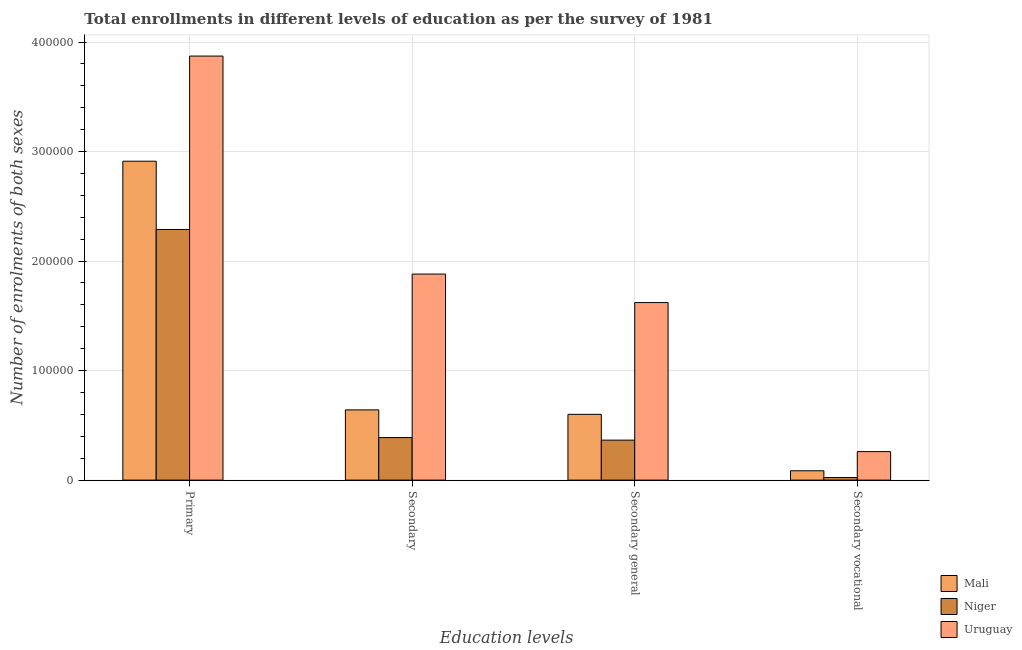How many different coloured bars are there?
Provide a succinct answer. 3. How many groups of bars are there?
Ensure brevity in your answer.  4. Are the number of bars on each tick of the X-axis equal?
Your answer should be compact. Yes. How many bars are there on the 1st tick from the left?
Ensure brevity in your answer.  3. What is the label of the 2nd group of bars from the left?
Make the answer very short. Secondary. What is the number of enrolments in secondary general education in Uruguay?
Provide a short and direct response. 1.62e+05. Across all countries, what is the maximum number of enrolments in secondary general education?
Provide a short and direct response. 1.62e+05. Across all countries, what is the minimum number of enrolments in primary education?
Provide a short and direct response. 2.29e+05. In which country was the number of enrolments in secondary general education maximum?
Make the answer very short. Uruguay. In which country was the number of enrolments in secondary education minimum?
Your answer should be compact. Niger. What is the total number of enrolments in secondary vocational education in the graph?
Provide a succinct answer. 3.69e+04. What is the difference between the number of enrolments in primary education in Uruguay and that in Mali?
Your answer should be compact. 9.60e+04. What is the difference between the number of enrolments in secondary general education in Niger and the number of enrolments in secondary education in Mali?
Your answer should be very brief. -2.76e+04. What is the average number of enrolments in secondary education per country?
Offer a terse response. 9.70e+04. What is the difference between the number of enrolments in secondary general education and number of enrolments in primary education in Mali?
Offer a terse response. -2.31e+05. What is the ratio of the number of enrolments in secondary education in Niger to that in Uruguay?
Offer a very short reply. 0.21. Is the number of enrolments in secondary vocational education in Mali less than that in Uruguay?
Your answer should be compact. Yes. Is the difference between the number of enrolments in secondary education in Niger and Mali greater than the difference between the number of enrolments in primary education in Niger and Mali?
Ensure brevity in your answer.  Yes. What is the difference between the highest and the second highest number of enrolments in secondary general education?
Give a very brief answer. 1.02e+05. What is the difference between the highest and the lowest number of enrolments in secondary education?
Your answer should be very brief. 1.49e+05. Is the sum of the number of enrolments in secondary vocational education in Niger and Uruguay greater than the maximum number of enrolments in secondary general education across all countries?
Ensure brevity in your answer.  No. What does the 2nd bar from the left in Primary represents?
Your answer should be compact. Niger. What does the 2nd bar from the right in Secondary represents?
Offer a very short reply. Niger. Where does the legend appear in the graph?
Offer a very short reply. Bottom right. How many legend labels are there?
Provide a succinct answer. 3. What is the title of the graph?
Your response must be concise. Total enrollments in different levels of education as per the survey of 1981. Does "Nicaragua" appear as one of the legend labels in the graph?
Provide a succinct answer. No. What is the label or title of the X-axis?
Offer a very short reply. Education levels. What is the label or title of the Y-axis?
Provide a succinct answer. Number of enrolments of both sexes. What is the Number of enrolments of both sexes in Mali in Primary?
Offer a very short reply. 2.91e+05. What is the Number of enrolments of both sexes of Niger in Primary?
Give a very brief answer. 2.29e+05. What is the Number of enrolments of both sexes in Uruguay in Primary?
Keep it short and to the point. 3.87e+05. What is the Number of enrolments of both sexes in Mali in Secondary?
Your answer should be compact. 6.41e+04. What is the Number of enrolments of both sexes of Niger in Secondary?
Provide a succinct answer. 3.89e+04. What is the Number of enrolments of both sexes in Uruguay in Secondary?
Offer a very short reply. 1.88e+05. What is the Number of enrolments of both sexes in Mali in Secondary general?
Provide a short and direct response. 6.01e+04. What is the Number of enrolments of both sexes of Niger in Secondary general?
Make the answer very short. 3.65e+04. What is the Number of enrolments of both sexes in Uruguay in Secondary general?
Offer a terse response. 1.62e+05. What is the Number of enrolments of both sexes of Mali in Secondary vocational?
Your answer should be very brief. 8537. What is the Number of enrolments of both sexes of Niger in Secondary vocational?
Provide a succinct answer. 2351. What is the Number of enrolments of both sexes in Uruguay in Secondary vocational?
Make the answer very short. 2.60e+04. Across all Education levels, what is the maximum Number of enrolments of both sexes in Mali?
Ensure brevity in your answer.  2.91e+05. Across all Education levels, what is the maximum Number of enrolments of both sexes in Niger?
Keep it short and to the point. 2.29e+05. Across all Education levels, what is the maximum Number of enrolments of both sexes in Uruguay?
Offer a terse response. 3.87e+05. Across all Education levels, what is the minimum Number of enrolments of both sexes of Mali?
Offer a terse response. 8537. Across all Education levels, what is the minimum Number of enrolments of both sexes in Niger?
Give a very brief answer. 2351. Across all Education levels, what is the minimum Number of enrolments of both sexes of Uruguay?
Your response must be concise. 2.60e+04. What is the total Number of enrolments of both sexes of Mali in the graph?
Ensure brevity in your answer.  4.24e+05. What is the total Number of enrolments of both sexes in Niger in the graph?
Provide a succinct answer. 3.07e+05. What is the total Number of enrolments of both sexes in Uruguay in the graph?
Ensure brevity in your answer.  7.63e+05. What is the difference between the Number of enrolments of both sexes in Mali in Primary and that in Secondary?
Provide a short and direct response. 2.27e+05. What is the difference between the Number of enrolments of both sexes of Niger in Primary and that in Secondary?
Your response must be concise. 1.90e+05. What is the difference between the Number of enrolments of both sexes of Uruguay in Primary and that in Secondary?
Keep it short and to the point. 1.99e+05. What is the difference between the Number of enrolments of both sexes of Mali in Primary and that in Secondary general?
Provide a succinct answer. 2.31e+05. What is the difference between the Number of enrolments of both sexes in Niger in Primary and that in Secondary general?
Make the answer very short. 1.92e+05. What is the difference between the Number of enrolments of both sexes in Uruguay in Primary and that in Secondary general?
Make the answer very short. 2.25e+05. What is the difference between the Number of enrolments of both sexes in Mali in Primary and that in Secondary vocational?
Provide a short and direct response. 2.83e+05. What is the difference between the Number of enrolments of both sexes in Niger in Primary and that in Secondary vocational?
Ensure brevity in your answer.  2.27e+05. What is the difference between the Number of enrolments of both sexes in Uruguay in Primary and that in Secondary vocational?
Keep it short and to the point. 3.61e+05. What is the difference between the Number of enrolments of both sexes of Mali in Secondary and that in Secondary general?
Provide a short and direct response. 4059. What is the difference between the Number of enrolments of both sexes in Niger in Secondary and that in Secondary general?
Provide a succinct answer. 2351. What is the difference between the Number of enrolments of both sexes of Uruguay in Secondary and that in Secondary general?
Your answer should be very brief. 2.60e+04. What is the difference between the Number of enrolments of both sexes of Mali in Secondary and that in Secondary vocational?
Offer a terse response. 5.56e+04. What is the difference between the Number of enrolments of both sexes in Niger in Secondary and that in Secondary vocational?
Make the answer very short. 3.65e+04. What is the difference between the Number of enrolments of both sexes of Uruguay in Secondary and that in Secondary vocational?
Offer a terse response. 1.62e+05. What is the difference between the Number of enrolments of both sexes in Mali in Secondary general and that in Secondary vocational?
Provide a succinct answer. 5.15e+04. What is the difference between the Number of enrolments of both sexes of Niger in Secondary general and that in Secondary vocational?
Give a very brief answer. 3.42e+04. What is the difference between the Number of enrolments of both sexes in Uruguay in Secondary general and that in Secondary vocational?
Your answer should be compact. 1.36e+05. What is the difference between the Number of enrolments of both sexes in Mali in Primary and the Number of enrolments of both sexes in Niger in Secondary?
Your response must be concise. 2.52e+05. What is the difference between the Number of enrolments of both sexes of Mali in Primary and the Number of enrolments of both sexes of Uruguay in Secondary?
Offer a very short reply. 1.03e+05. What is the difference between the Number of enrolments of both sexes in Niger in Primary and the Number of enrolments of both sexes in Uruguay in Secondary?
Your response must be concise. 4.07e+04. What is the difference between the Number of enrolments of both sexes of Mali in Primary and the Number of enrolments of both sexes of Niger in Secondary general?
Ensure brevity in your answer.  2.55e+05. What is the difference between the Number of enrolments of both sexes of Mali in Primary and the Number of enrolments of both sexes of Uruguay in Secondary general?
Provide a short and direct response. 1.29e+05. What is the difference between the Number of enrolments of both sexes in Niger in Primary and the Number of enrolments of both sexes in Uruguay in Secondary general?
Ensure brevity in your answer.  6.67e+04. What is the difference between the Number of enrolments of both sexes in Mali in Primary and the Number of enrolments of both sexes in Niger in Secondary vocational?
Your answer should be very brief. 2.89e+05. What is the difference between the Number of enrolments of both sexes in Mali in Primary and the Number of enrolments of both sexes in Uruguay in Secondary vocational?
Make the answer very short. 2.65e+05. What is the difference between the Number of enrolments of both sexes of Niger in Primary and the Number of enrolments of both sexes of Uruguay in Secondary vocational?
Keep it short and to the point. 2.03e+05. What is the difference between the Number of enrolments of both sexes of Mali in Secondary and the Number of enrolments of both sexes of Niger in Secondary general?
Offer a very short reply. 2.76e+04. What is the difference between the Number of enrolments of both sexes in Mali in Secondary and the Number of enrolments of both sexes in Uruguay in Secondary general?
Your answer should be very brief. -9.80e+04. What is the difference between the Number of enrolments of both sexes in Niger in Secondary and the Number of enrolments of both sexes in Uruguay in Secondary general?
Offer a terse response. -1.23e+05. What is the difference between the Number of enrolments of both sexes of Mali in Secondary and the Number of enrolments of both sexes of Niger in Secondary vocational?
Provide a short and direct response. 6.18e+04. What is the difference between the Number of enrolments of both sexes of Mali in Secondary and the Number of enrolments of both sexes of Uruguay in Secondary vocational?
Offer a very short reply. 3.81e+04. What is the difference between the Number of enrolments of both sexes in Niger in Secondary and the Number of enrolments of both sexes in Uruguay in Secondary vocational?
Ensure brevity in your answer.  1.28e+04. What is the difference between the Number of enrolments of both sexes in Mali in Secondary general and the Number of enrolments of both sexes in Niger in Secondary vocational?
Keep it short and to the point. 5.77e+04. What is the difference between the Number of enrolments of both sexes of Mali in Secondary general and the Number of enrolments of both sexes of Uruguay in Secondary vocational?
Give a very brief answer. 3.40e+04. What is the difference between the Number of enrolments of both sexes of Niger in Secondary general and the Number of enrolments of both sexes of Uruguay in Secondary vocational?
Keep it short and to the point. 1.05e+04. What is the average Number of enrolments of both sexes in Mali per Education levels?
Give a very brief answer. 1.06e+05. What is the average Number of enrolments of both sexes of Niger per Education levels?
Ensure brevity in your answer.  7.66e+04. What is the average Number of enrolments of both sexes in Uruguay per Education levels?
Offer a terse response. 1.91e+05. What is the difference between the Number of enrolments of both sexes in Mali and Number of enrolments of both sexes in Niger in Primary?
Offer a terse response. 6.23e+04. What is the difference between the Number of enrolments of both sexes of Mali and Number of enrolments of both sexes of Uruguay in Primary?
Keep it short and to the point. -9.60e+04. What is the difference between the Number of enrolments of both sexes of Niger and Number of enrolments of both sexes of Uruguay in Primary?
Offer a terse response. -1.58e+05. What is the difference between the Number of enrolments of both sexes of Mali and Number of enrolments of both sexes of Niger in Secondary?
Give a very brief answer. 2.53e+04. What is the difference between the Number of enrolments of both sexes in Mali and Number of enrolments of both sexes in Uruguay in Secondary?
Make the answer very short. -1.24e+05. What is the difference between the Number of enrolments of both sexes in Niger and Number of enrolments of both sexes in Uruguay in Secondary?
Your response must be concise. -1.49e+05. What is the difference between the Number of enrolments of both sexes of Mali and Number of enrolments of both sexes of Niger in Secondary general?
Give a very brief answer. 2.36e+04. What is the difference between the Number of enrolments of both sexes in Mali and Number of enrolments of both sexes in Uruguay in Secondary general?
Keep it short and to the point. -1.02e+05. What is the difference between the Number of enrolments of both sexes of Niger and Number of enrolments of both sexes of Uruguay in Secondary general?
Give a very brief answer. -1.26e+05. What is the difference between the Number of enrolments of both sexes of Mali and Number of enrolments of both sexes of Niger in Secondary vocational?
Provide a succinct answer. 6186. What is the difference between the Number of enrolments of both sexes of Mali and Number of enrolments of both sexes of Uruguay in Secondary vocational?
Your answer should be very brief. -1.75e+04. What is the difference between the Number of enrolments of both sexes of Niger and Number of enrolments of both sexes of Uruguay in Secondary vocational?
Your response must be concise. -2.37e+04. What is the ratio of the Number of enrolments of both sexes in Mali in Primary to that in Secondary?
Your response must be concise. 4.54. What is the ratio of the Number of enrolments of both sexes in Niger in Primary to that in Secondary?
Give a very brief answer. 5.89. What is the ratio of the Number of enrolments of both sexes of Uruguay in Primary to that in Secondary?
Your response must be concise. 2.06. What is the ratio of the Number of enrolments of both sexes of Mali in Primary to that in Secondary general?
Offer a very short reply. 4.85. What is the ratio of the Number of enrolments of both sexes of Niger in Primary to that in Secondary general?
Your answer should be compact. 6.27. What is the ratio of the Number of enrolments of both sexes of Uruguay in Primary to that in Secondary general?
Offer a very short reply. 2.39. What is the ratio of the Number of enrolments of both sexes of Mali in Primary to that in Secondary vocational?
Offer a terse response. 34.11. What is the ratio of the Number of enrolments of both sexes of Niger in Primary to that in Secondary vocational?
Offer a very short reply. 97.34. What is the ratio of the Number of enrolments of both sexes in Uruguay in Primary to that in Secondary vocational?
Keep it short and to the point. 14.88. What is the ratio of the Number of enrolments of both sexes in Mali in Secondary to that in Secondary general?
Your answer should be compact. 1.07. What is the ratio of the Number of enrolments of both sexes of Niger in Secondary to that in Secondary general?
Offer a very short reply. 1.06. What is the ratio of the Number of enrolments of both sexes of Uruguay in Secondary to that in Secondary general?
Your answer should be compact. 1.16. What is the ratio of the Number of enrolments of both sexes in Mali in Secondary to that in Secondary vocational?
Make the answer very short. 7.51. What is the ratio of the Number of enrolments of both sexes in Niger in Secondary to that in Secondary vocational?
Your answer should be compact. 16.53. What is the ratio of the Number of enrolments of both sexes of Uruguay in Secondary to that in Secondary vocational?
Provide a succinct answer. 7.23. What is the ratio of the Number of enrolments of both sexes in Mali in Secondary general to that in Secondary vocational?
Your answer should be compact. 7.04. What is the ratio of the Number of enrolments of both sexes in Niger in Secondary general to that in Secondary vocational?
Give a very brief answer. 15.53. What is the ratio of the Number of enrolments of both sexes of Uruguay in Secondary general to that in Secondary vocational?
Give a very brief answer. 6.23. What is the difference between the highest and the second highest Number of enrolments of both sexes in Mali?
Your answer should be very brief. 2.27e+05. What is the difference between the highest and the second highest Number of enrolments of both sexes in Niger?
Make the answer very short. 1.90e+05. What is the difference between the highest and the second highest Number of enrolments of both sexes of Uruguay?
Keep it short and to the point. 1.99e+05. What is the difference between the highest and the lowest Number of enrolments of both sexes of Mali?
Offer a very short reply. 2.83e+05. What is the difference between the highest and the lowest Number of enrolments of both sexes in Niger?
Keep it short and to the point. 2.27e+05. What is the difference between the highest and the lowest Number of enrolments of both sexes in Uruguay?
Ensure brevity in your answer.  3.61e+05. 